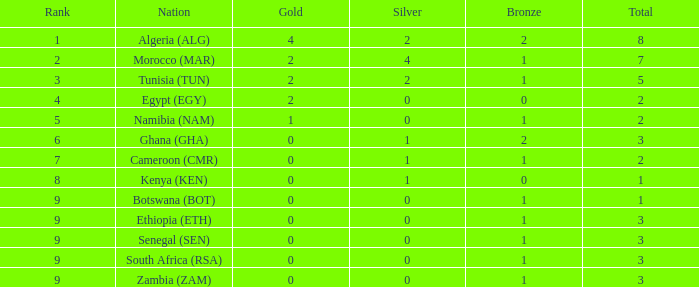What is the average Total with a Nation of ethiopia (eth) and a Rank that is larger than 9? None. 